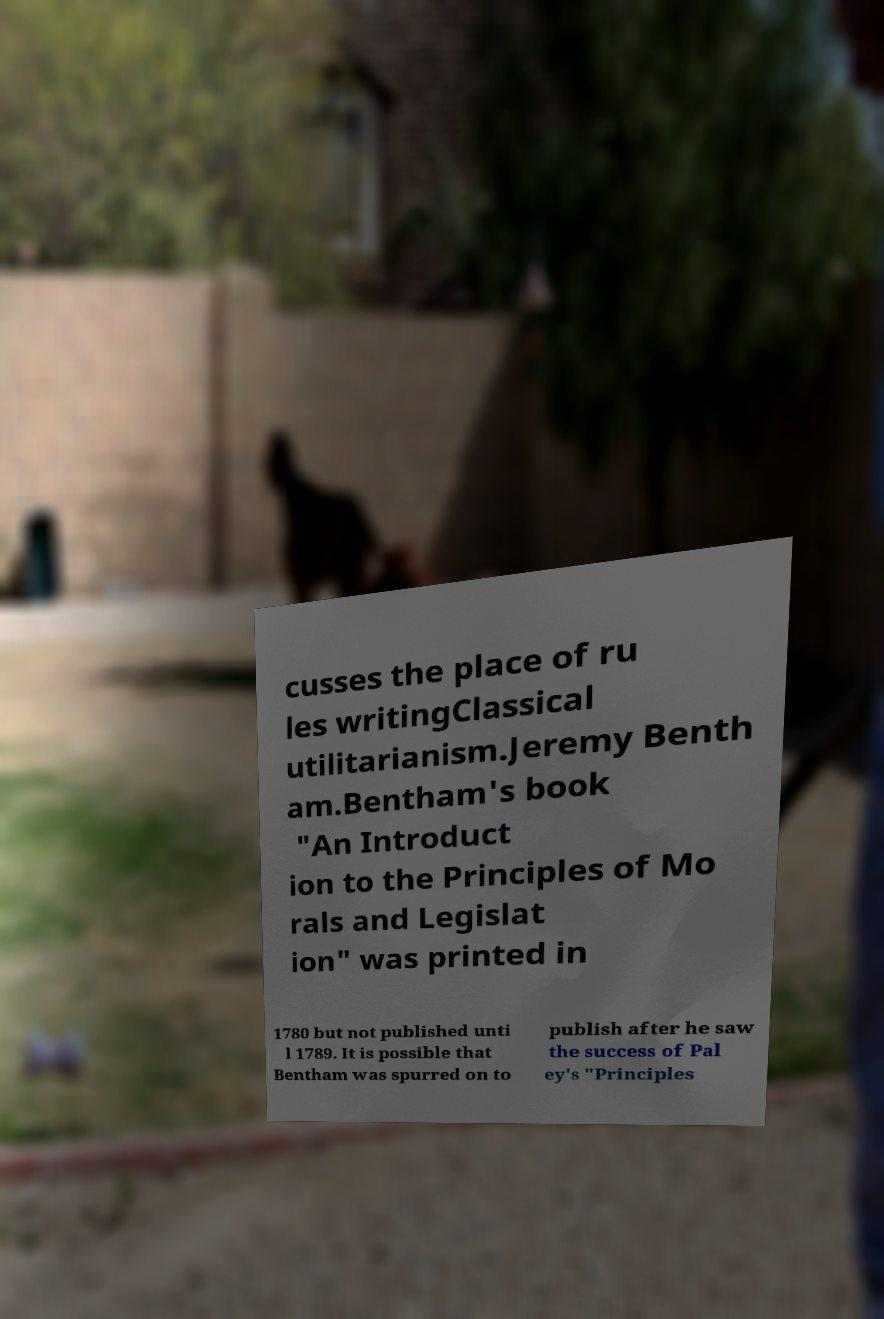Can you accurately transcribe the text from the provided image for me? cusses the place of ru les writingClassical utilitarianism.Jeremy Benth am.Bentham's book "An Introduct ion to the Principles of Mo rals and Legislat ion" was printed in 1780 but not published unti l 1789. It is possible that Bentham was spurred on to publish after he saw the success of Pal ey's "Principles 